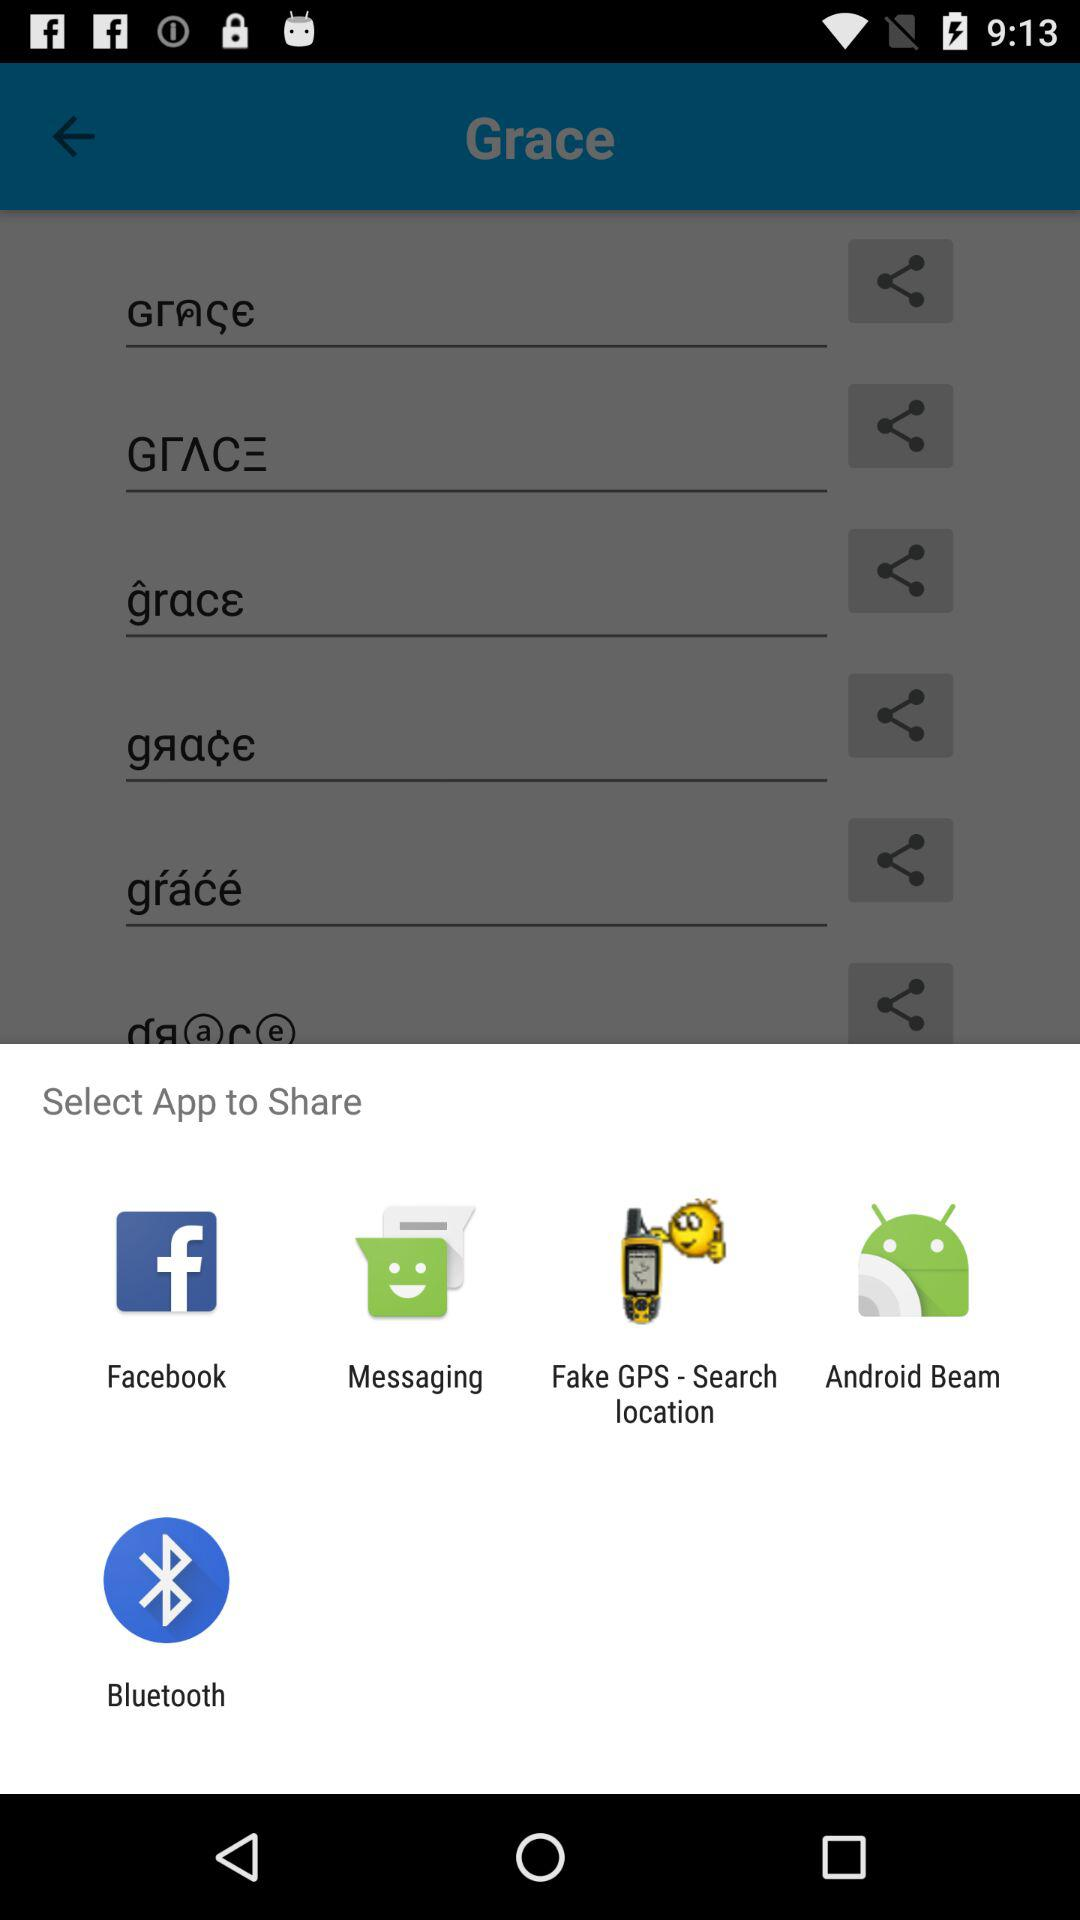Through which applications can we share? You can share through "Facebook", "Messaging", "Fake GPS - Search location", "Android Beam" and "Bluetooth". 